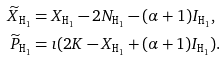Convert formula to latex. <formula><loc_0><loc_0><loc_500><loc_500>\widetilde { X } _ { { \tt H } _ { 1 } } & = X _ { { \tt H } _ { 1 } } - 2 N _ { { \tt H } _ { 1 } } - ( \alpha + 1 ) I _ { { \tt H } _ { 1 } } , \\ \widetilde { P } _ { { \tt H } _ { 1 } } & = \imath ( 2 K - X _ { { \tt H } _ { 1 } } + ( \alpha + 1 ) I _ { { \tt H } _ { 1 } } ) .</formula> 